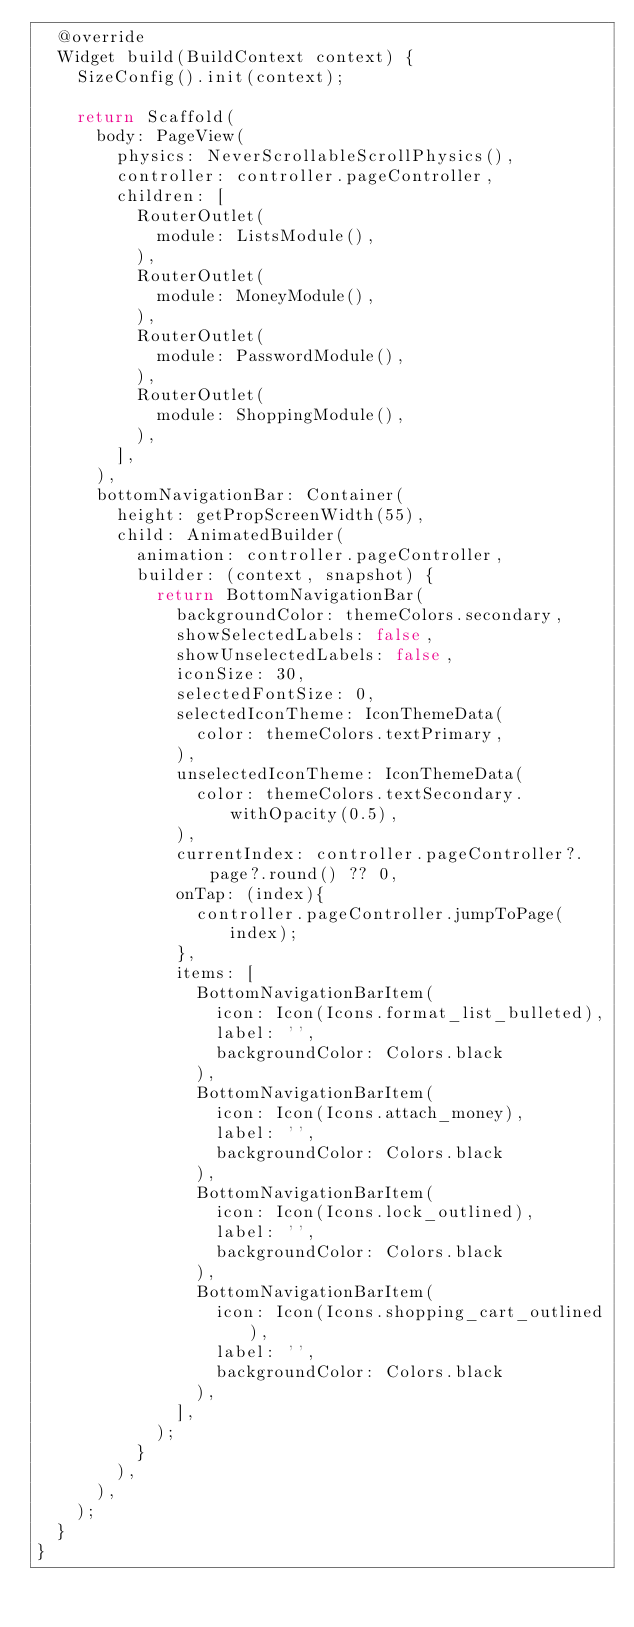Convert code to text. <code><loc_0><loc_0><loc_500><loc_500><_Dart_>  @override
  Widget build(BuildContext context) {
    SizeConfig().init(context);

    return Scaffold(
      body: PageView(
        physics: NeverScrollableScrollPhysics(),
        controller: controller.pageController,
        children: [
          RouterOutlet(
            module: ListsModule(),
          ),
          RouterOutlet(
            module: MoneyModule(),
          ),
          RouterOutlet(
            module: PasswordModule(),
          ),
          RouterOutlet(
            module: ShoppingModule(),
          ),
        ],
      ),
      bottomNavigationBar: Container(
        height: getPropScreenWidth(55),
        child: AnimatedBuilder(
          animation: controller.pageController,
          builder: (context, snapshot) {
            return BottomNavigationBar(
              backgroundColor: themeColors.secondary,
              showSelectedLabels: false,
              showUnselectedLabels: false,
              iconSize: 30,
              selectedFontSize: 0,
              selectedIconTheme: IconThemeData(
                color: themeColors.textPrimary,
              ),
              unselectedIconTheme: IconThemeData(
                color: themeColors.textSecondary.withOpacity(0.5),
              ),
              currentIndex: controller.pageController?.page?.round() ?? 0,
              onTap: (index){
                controller.pageController.jumpToPage(index);
              },
              items: [
                BottomNavigationBarItem(
                  icon: Icon(Icons.format_list_bulleted),
                  label: '',
                  backgroundColor: Colors.black
                ),
                BottomNavigationBarItem(
                  icon: Icon(Icons.attach_money),
                  label: '',
                  backgroundColor: Colors.black
                ),
                BottomNavigationBarItem(
                  icon: Icon(Icons.lock_outlined),
                  label: '',
                  backgroundColor: Colors.black
                ),
                BottomNavigationBarItem(
                  icon: Icon(Icons.shopping_cart_outlined),
                  label: '',
                  backgroundColor: Colors.black
                ),
              ],
            );
          }
        ),
      ),
    );
  }
}
</code> 